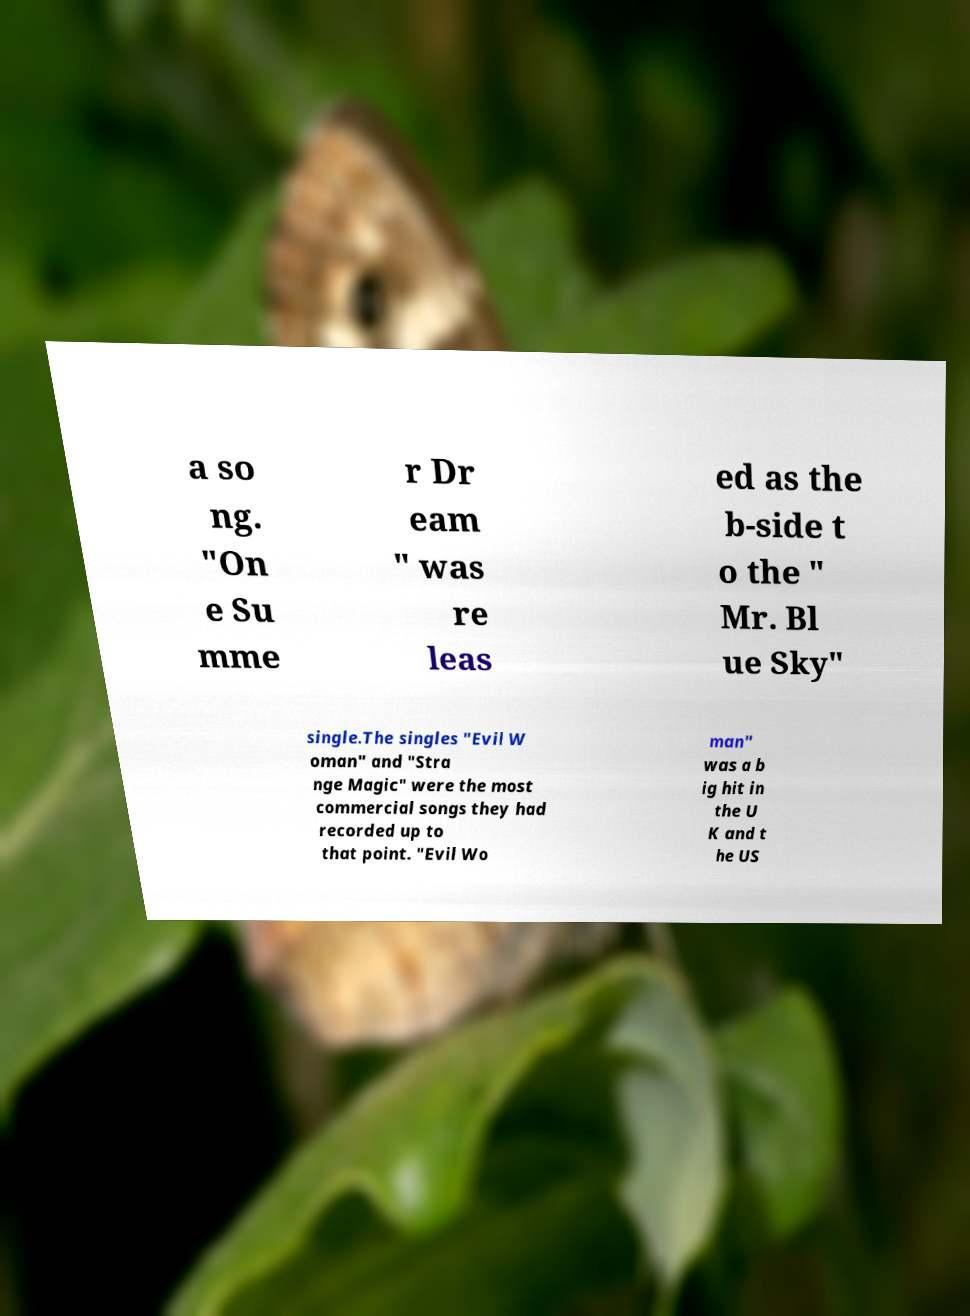Please read and relay the text visible in this image. What does it say? a so ng. "On e Su mme r Dr eam " was re leas ed as the b-side t o the " Mr. Bl ue Sky" single.The singles "Evil W oman" and "Stra nge Magic" were the most commercial songs they had recorded up to that point. "Evil Wo man" was a b ig hit in the U K and t he US 